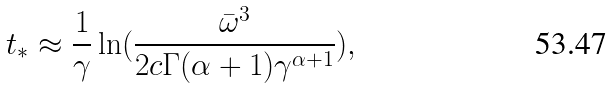Convert formula to latex. <formula><loc_0><loc_0><loc_500><loc_500>t _ { * } \approx \frac { 1 } { \gamma } \ln ( \frac { \bar { \omega } ^ { 3 } } { 2 c \Gamma ( \alpha + 1 ) \gamma ^ { \alpha + 1 } } ) ,</formula> 